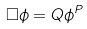<formula> <loc_0><loc_0><loc_500><loc_500>\Box \phi = Q \phi ^ { P }</formula> 